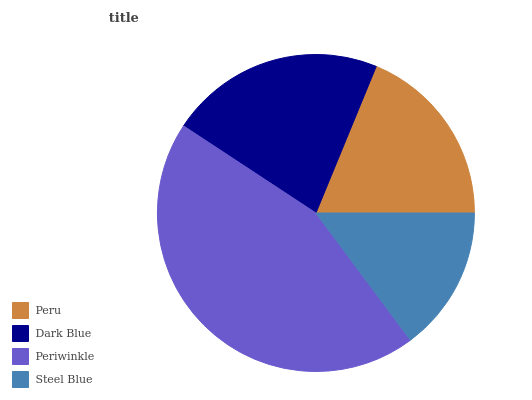Is Steel Blue the minimum?
Answer yes or no. Yes. Is Periwinkle the maximum?
Answer yes or no. Yes. Is Dark Blue the minimum?
Answer yes or no. No. Is Dark Blue the maximum?
Answer yes or no. No. Is Dark Blue greater than Peru?
Answer yes or no. Yes. Is Peru less than Dark Blue?
Answer yes or no. Yes. Is Peru greater than Dark Blue?
Answer yes or no. No. Is Dark Blue less than Peru?
Answer yes or no. No. Is Dark Blue the high median?
Answer yes or no. Yes. Is Peru the low median?
Answer yes or no. Yes. Is Periwinkle the high median?
Answer yes or no. No. Is Steel Blue the low median?
Answer yes or no. No. 